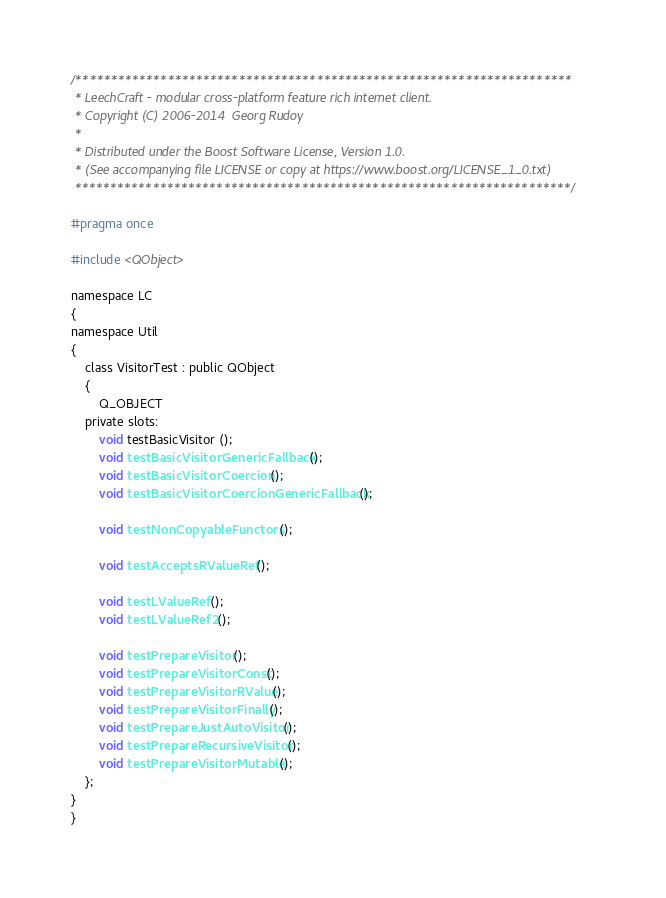Convert code to text. <code><loc_0><loc_0><loc_500><loc_500><_C_>/**********************************************************************
 * LeechCraft - modular cross-platform feature rich internet client.
 * Copyright (C) 2006-2014  Georg Rudoy
 *
 * Distributed under the Boost Software License, Version 1.0.
 * (See accompanying file LICENSE or copy at https://www.boost.org/LICENSE_1_0.txt)
 **********************************************************************/

#pragma once

#include <QObject>

namespace LC
{
namespace Util
{
	class VisitorTest : public QObject
	{
		Q_OBJECT
	private slots:
		void testBasicVisitor ();
		void testBasicVisitorGenericFallback ();
		void testBasicVisitorCoercion ();
		void testBasicVisitorCoercionGenericFallback ();

		void testNonCopyableFunctors ();

		void testAcceptsRValueRef ();

		void testLValueRef ();
		void testLValueRef2 ();

		void testPrepareVisitor ();
		void testPrepareVisitorConst ();
		void testPrepareVisitorRValue ();
		void testPrepareVisitorFinally ();
		void testPrepareJustAutoVisitor ();
		void testPrepareRecursiveVisitor ();
		void testPrepareVisitorMutable ();
	};
}
}
</code> 